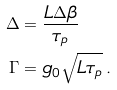Convert formula to latex. <formula><loc_0><loc_0><loc_500><loc_500>\Delta & = \frac { L \Delta \beta } { \tau _ { p } } \\ \Gamma & = g _ { 0 } \sqrt { L \tau _ { p } } \, .</formula> 